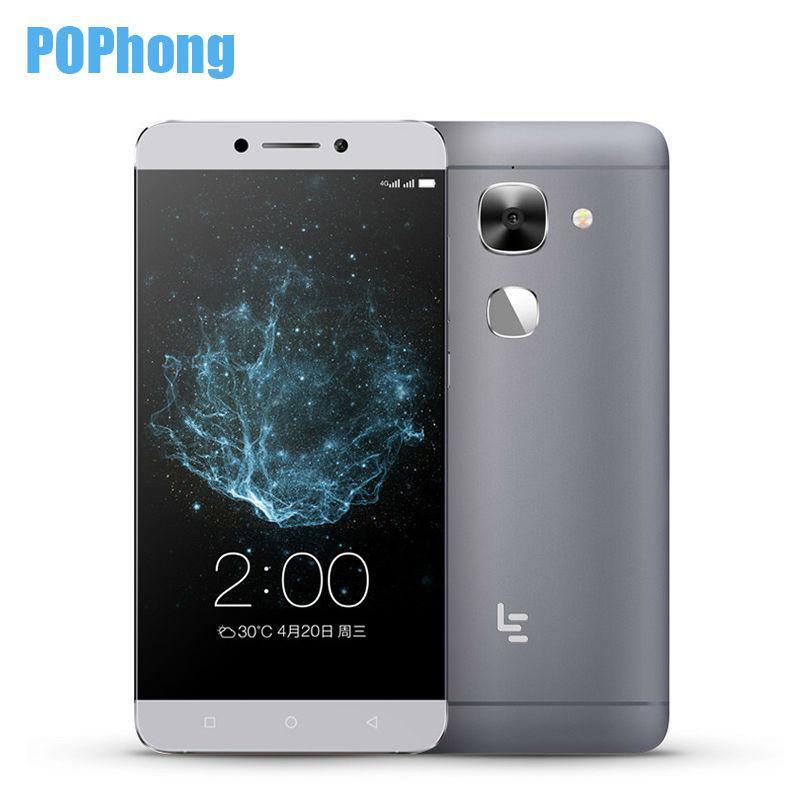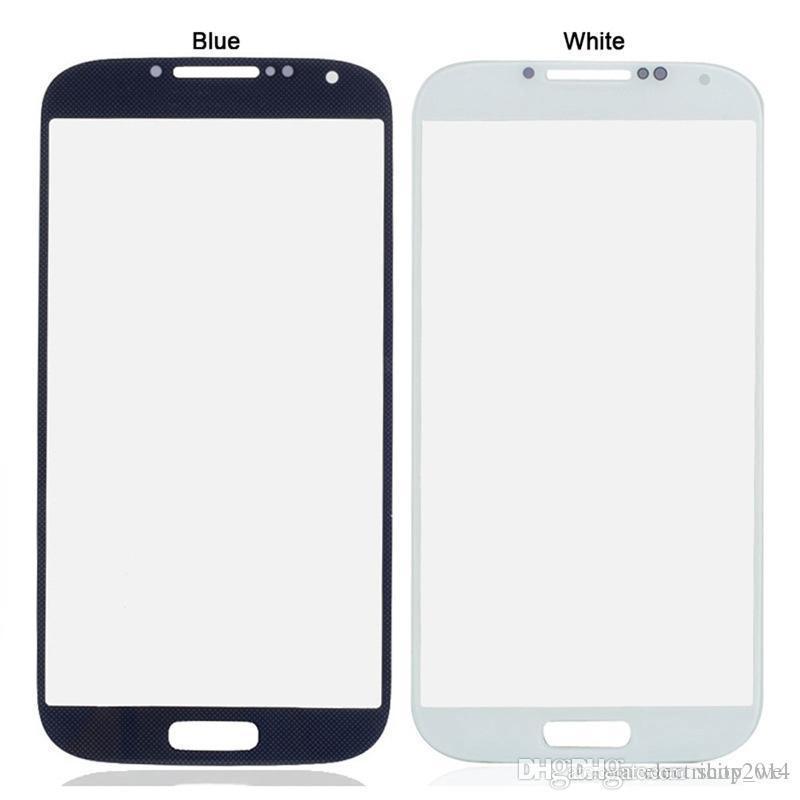The first image is the image on the left, the second image is the image on the right. Assess this claim about the two images: "At least one image includes a side-view of a phone to the right of two head-on displayed devices.". Correct or not? Answer yes or no. No. The first image is the image on the left, the second image is the image on the right. Assess this claim about the two images: "There is a side profile of at least one phone.". Correct or not? Answer yes or no. No. 